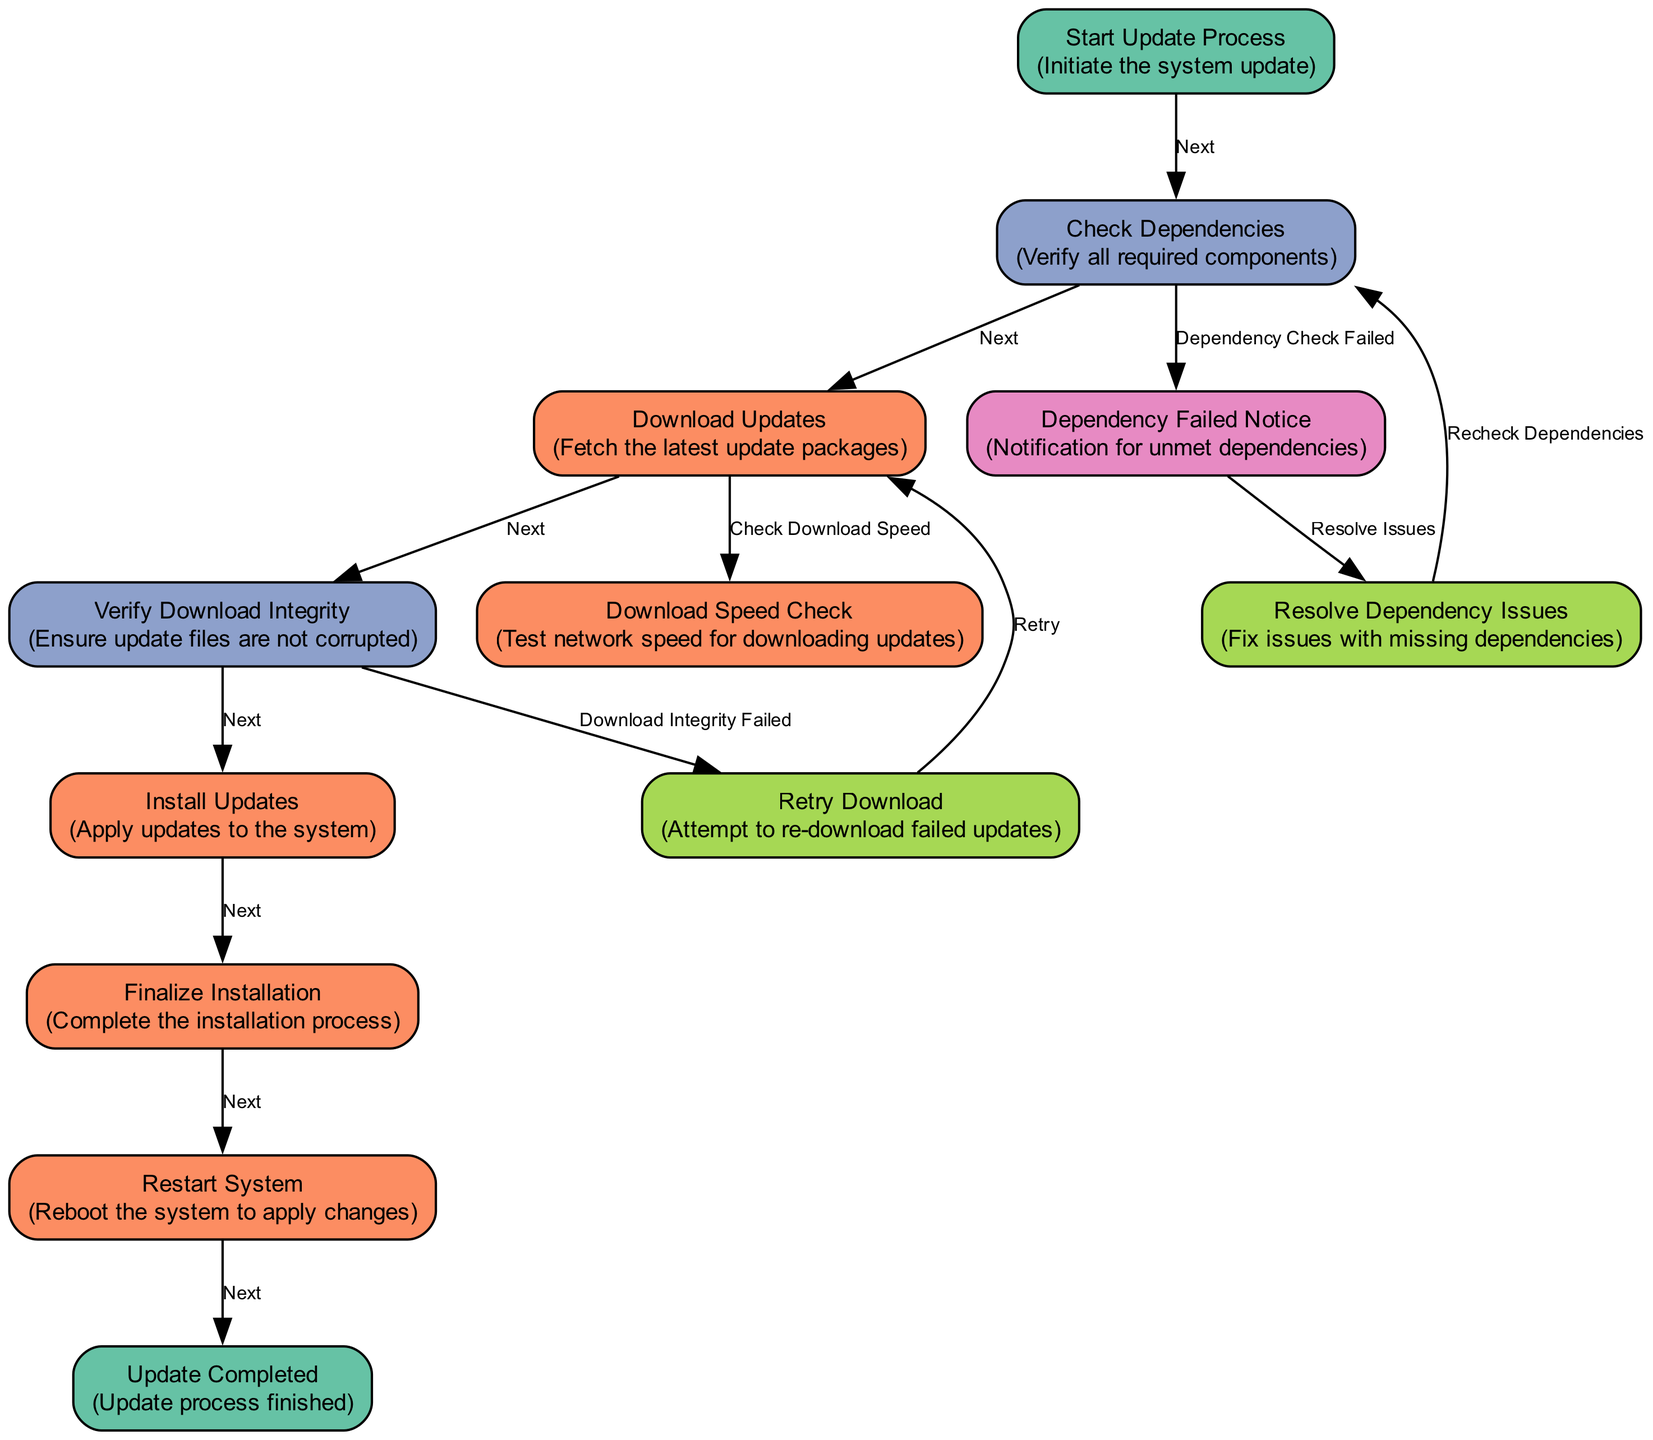What's the starting node of the update process? The diagram indicates that the update process starts with the node labeled "Start Update Process," which has an ID of 1.
Answer: Start Update Process How many total nodes are in the diagram? By counting all the entries in the "nodes" section of the provided data, we find there are 12 distinct nodes.
Answer: 12 What does the node labeled "Verify Download Integrity" lead to? The "Verify Download Integrity" node (ID 4) has two edges; one leads to "Install Updates" (ID 5) and another directs to "Retry Download" (ID 11). Thus, it leads to both nodes.
Answer: Install Updates, Retry Download What happens if the "Check Dependencies" fails? The flow from the "Check Dependencies" node (ID 2) to the "Dependency Failed Notice" node (ID 10) indicates that if dependencies are not met, the process continues to this notification.
Answer: Dependency Failed Notice What is the final node in the process? Upon completion of the update process, the flow directed to the node "Update Completed," which indicates the end of the process, making it the final node.
Answer: Update Completed Which node corresponds to checking the speed for downloading updates? The node labeled "Download Speed Check" (ID 9) specifically corresponds to testing the network speed prior to downloading the updates.
Answer: Download Speed Check If the integrity check fails during the download, what is the next step? The "Download Integrity Failed" edge from the "Verify Download Integrity" (ID 4) leads to "Retry Download" (ID 11), indicating that the next action is to attempt downloading again.
Answer: Retry Download What are the possible next actions after resolving dependency issues? The "Resolve Dependency Issues" node (ID 12) has a directed edge back to "Check Dependencies" (ID 2), indicating that the next action is to recheck the dependencies.
Answer: Check Dependencies Which process occurs directly after installing the updates? The process immediately following "Install Updates" (ID 5) according to the flow in the diagram is "Finalize Installation" (ID 6).
Answer: Finalize Installation 